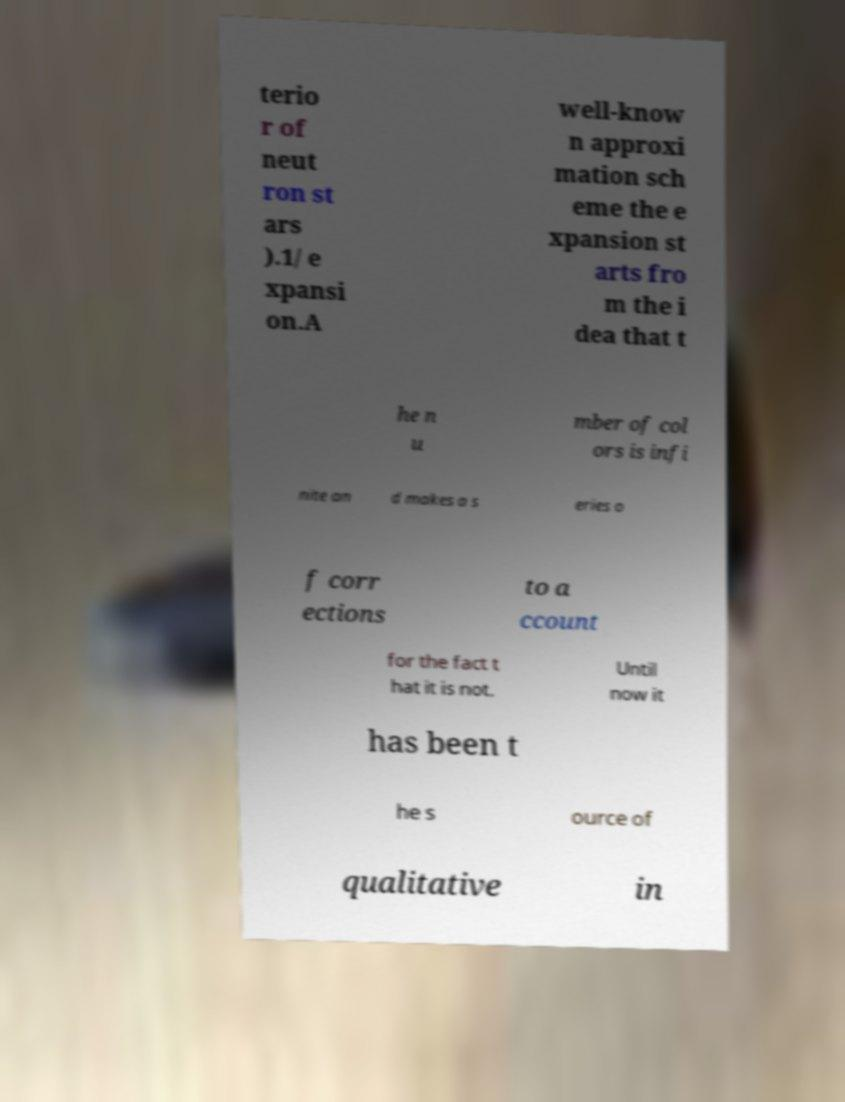Could you extract and type out the text from this image? terio r of neut ron st ars ).1/ e xpansi on.A well-know n approxi mation sch eme the e xpansion st arts fro m the i dea that t he n u mber of col ors is infi nite an d makes a s eries o f corr ections to a ccount for the fact t hat it is not. Until now it has been t he s ource of qualitative in 